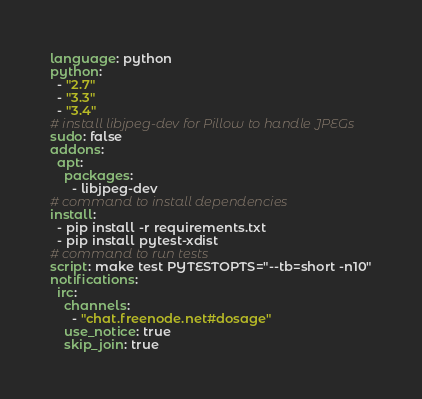Convert code to text. <code><loc_0><loc_0><loc_500><loc_500><_YAML_>language: python
python:
  - "2.7"
  - "3.3"
  - "3.4"
# install libjpeg-dev for Pillow to handle JPEGs
sudo: false
addons:
  apt:
    packages:
      - libjpeg-dev
# command to install dependencies
install:
  - pip install -r requirements.txt
  - pip install pytest-xdist
# command to run tests
script: make test PYTESTOPTS="--tb=short -n10"
notifications:
  irc:
    channels:
      - "chat.freenode.net#dosage"
    use_notice: true
    skip_join: true
</code> 